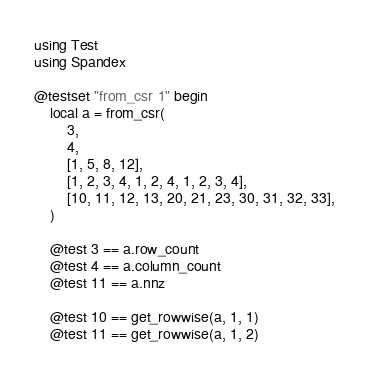<code> <loc_0><loc_0><loc_500><loc_500><_Julia_>using Test
using Spandex

@testset "from_csr 1" begin
    local a = from_csr(
        3,
        4,
        [1, 5, 8, 12],
        [1, 2, 3, 4, 1, 2, 4, 1, 2, 3, 4],
        [10, 11, 12, 13, 20, 21, 23, 30, 31, 32, 33],
    )

    @test 3 == a.row_count
    @test 4 == a.column_count
    @test 11 == a.nnz

    @test 10 == get_rowwise(a, 1, 1)
    @test 11 == get_rowwise(a, 1, 2)</code> 